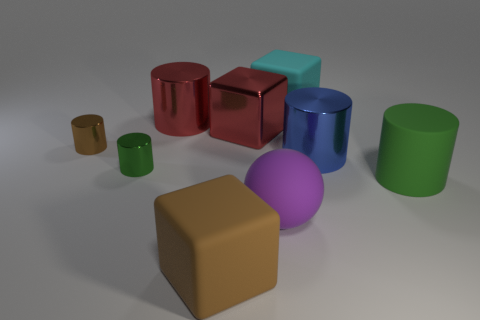What number of other things are the same size as the cyan cube?
Make the answer very short. 6. The green cylinder that is on the left side of the big matte object on the right side of the large shiny thing on the right side of the purple rubber ball is made of what material?
Provide a succinct answer. Metal. Does the large brown matte object have the same shape as the cyan matte thing?
Your answer should be compact. Yes. What number of shiny things are either red cylinders or tiny cylinders?
Make the answer very short. 3. How many rubber things are there?
Ensure brevity in your answer.  4. What is the color of the thing that is the same size as the green metal cylinder?
Make the answer very short. Brown. Do the cyan block and the blue metal thing have the same size?
Give a very brief answer. Yes. There is a brown shiny thing; does it have the same size as the green thing on the left side of the large rubber sphere?
Provide a short and direct response. Yes. What is the color of the large thing that is both to the right of the large brown rubber block and in front of the big green cylinder?
Keep it short and to the point. Purple. Is the number of shiny things behind the blue metal thing greater than the number of big green rubber cylinders that are in front of the large rubber cylinder?
Your response must be concise. Yes. 